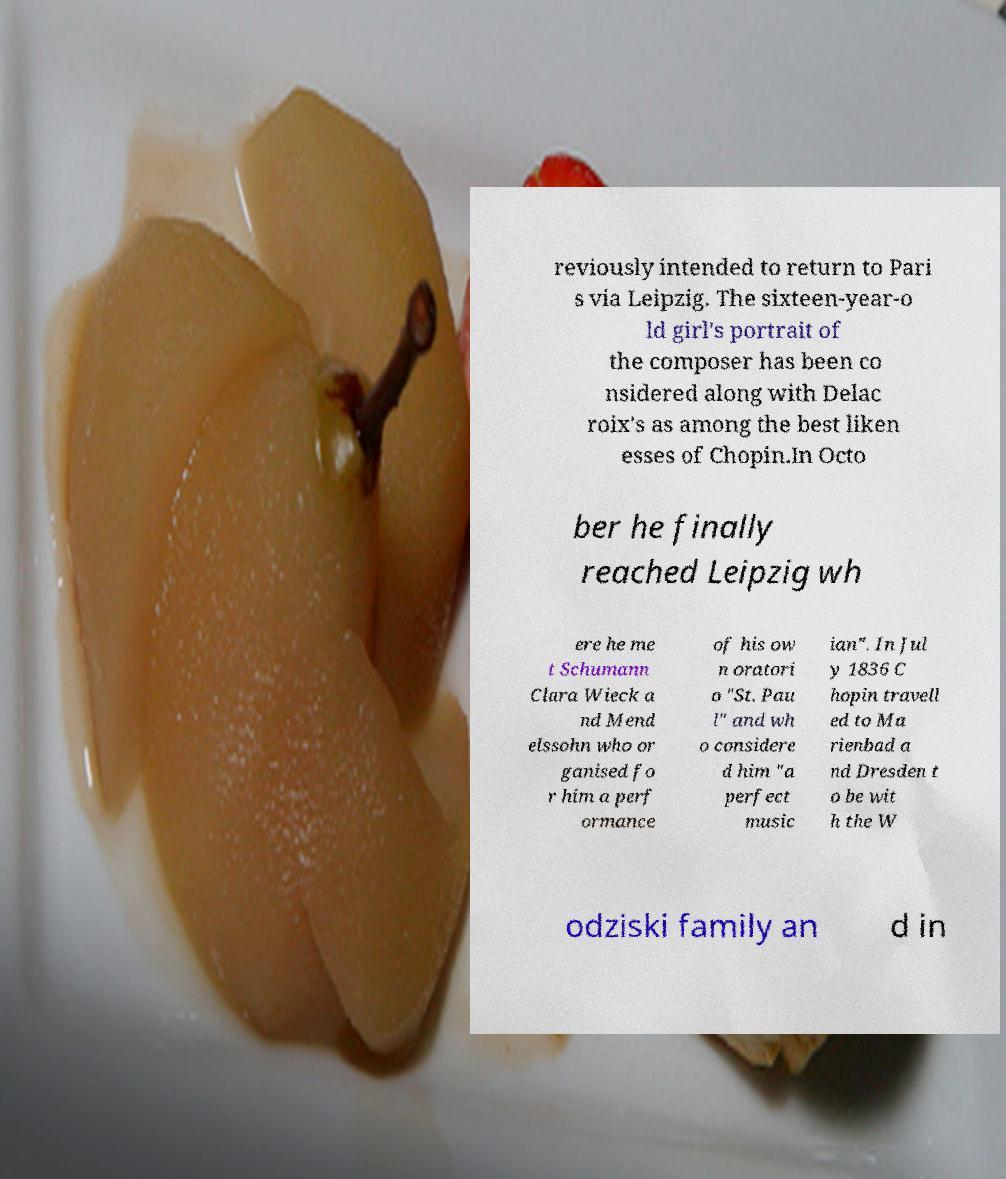I need the written content from this picture converted into text. Can you do that? reviously intended to return to Pari s via Leipzig. The sixteen-year-o ld girl's portrait of the composer has been co nsidered along with Delac roix's as among the best liken esses of Chopin.In Octo ber he finally reached Leipzig wh ere he me t Schumann Clara Wieck a nd Mend elssohn who or ganised fo r him a perf ormance of his ow n oratori o "St. Pau l" and wh o considere d him "a perfect music ian". In Jul y 1836 C hopin travell ed to Ma rienbad a nd Dresden t o be wit h the W odziski family an d in 